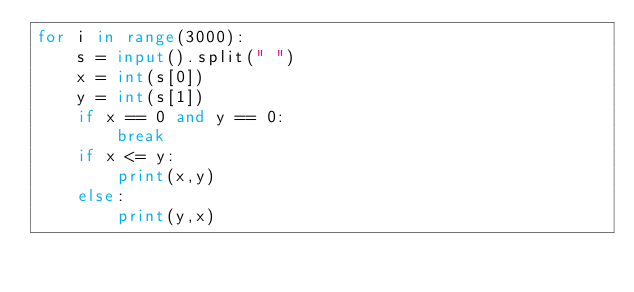Convert code to text. <code><loc_0><loc_0><loc_500><loc_500><_Python_>for i in range(3000):
    s = input().split(" ")
    x = int(s[0])
    y = int(s[1])
    if x == 0 and y == 0:
        break
    if x <= y:
        print(x,y)
    else:
        print(y,x)</code> 